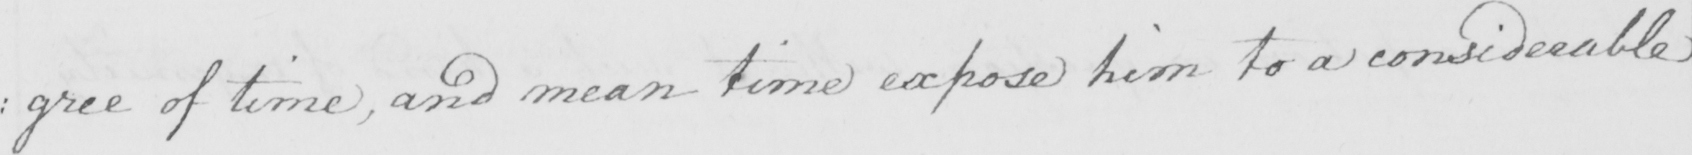Please transcribe the handwritten text in this image. : gree of time , and mean time expose him to a considerable 